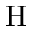Convert formula to latex. <formula><loc_0><loc_0><loc_500><loc_500>H</formula> 